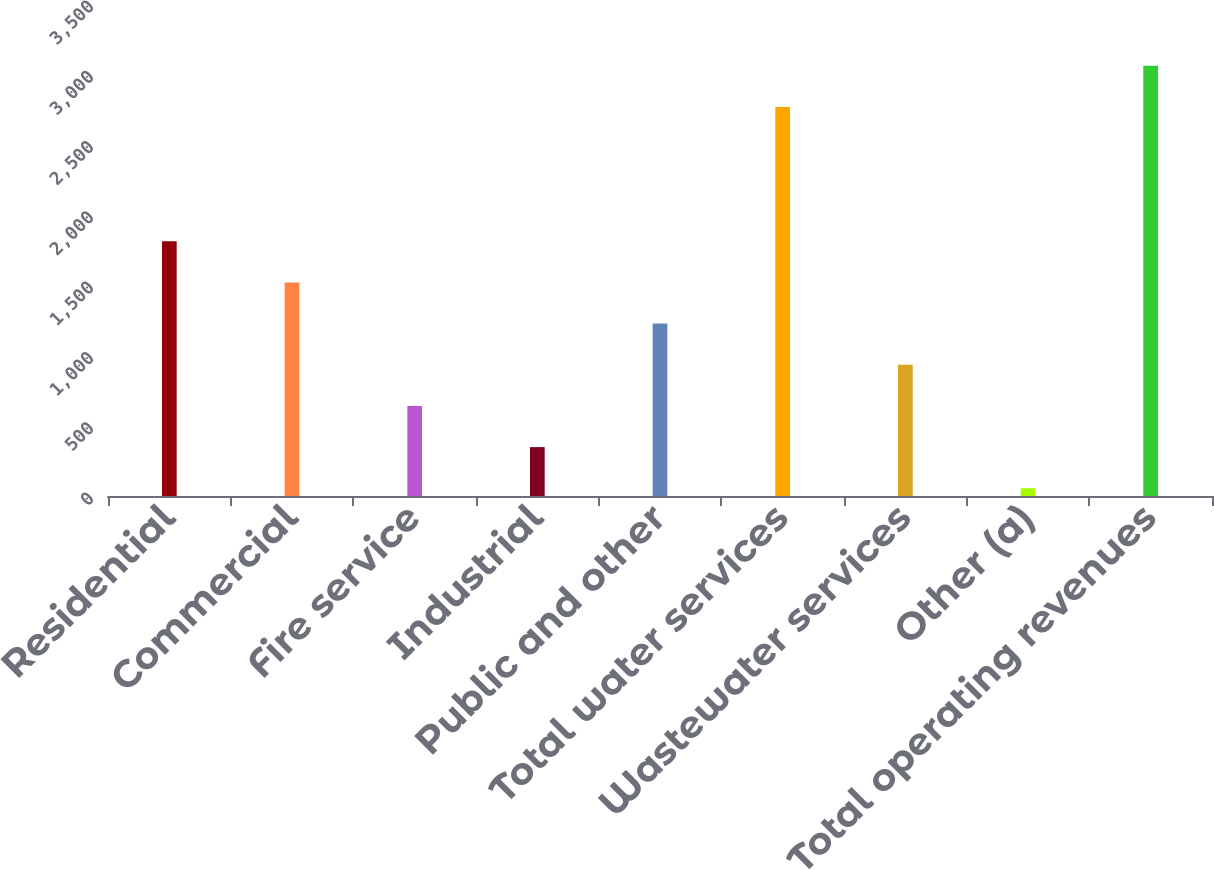<chart> <loc_0><loc_0><loc_500><loc_500><bar_chart><fcel>Residential<fcel>Commercial<fcel>Fire service<fcel>Industrial<fcel>Public and other<fcel>Total water services<fcel>Wastewater services<fcel>Other (a)<fcel>Total operating revenues<nl><fcel>1812.4<fcel>1519.5<fcel>640.8<fcel>347.9<fcel>1226.6<fcel>2768<fcel>933.7<fcel>55<fcel>3060.9<nl></chart> 